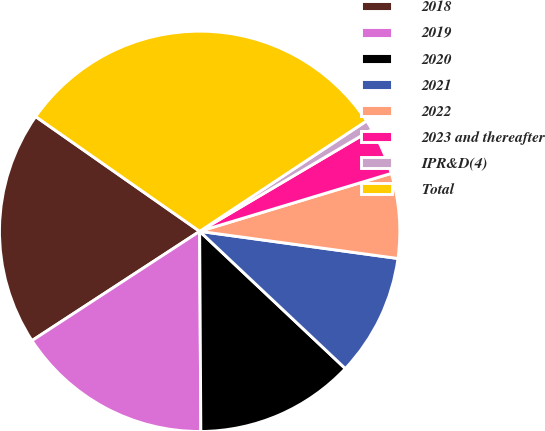Convert chart. <chart><loc_0><loc_0><loc_500><loc_500><pie_chart><fcel>2018<fcel>2019<fcel>2020<fcel>2021<fcel>2022<fcel>2023 and thereafter<fcel>IPR&D(4)<fcel>Total<nl><fcel>18.91%<fcel>15.9%<fcel>12.88%<fcel>9.86%<fcel>6.84%<fcel>3.82%<fcel>0.81%<fcel>30.98%<nl></chart> 